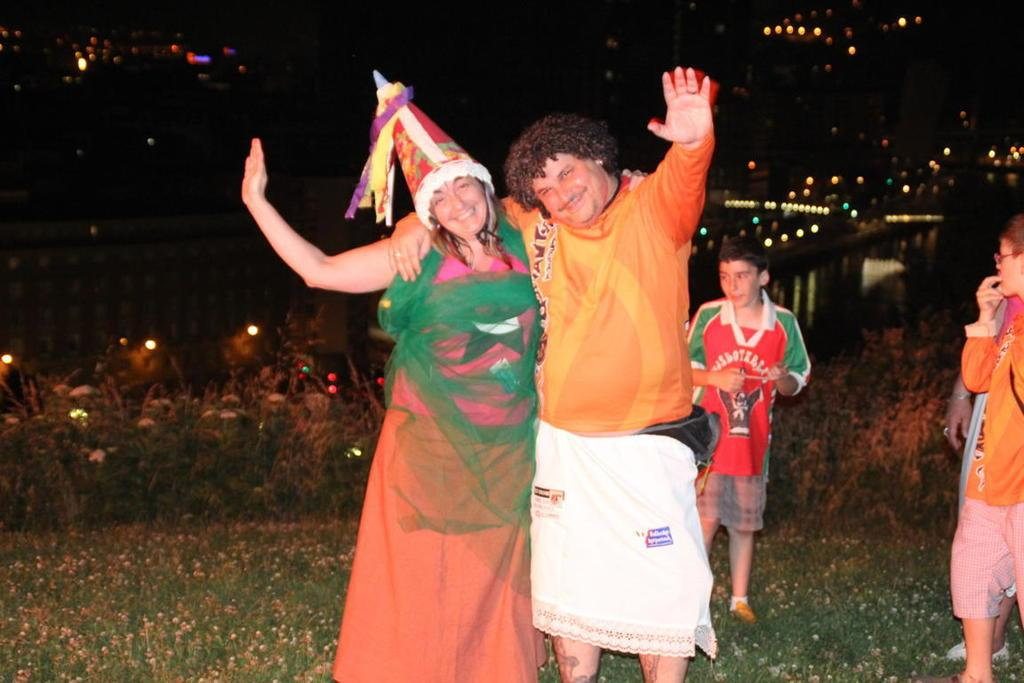Who or what can be seen in the image? There are people in the image. What else is present in the image besides people? There are plants, lights, and a fence in the image. What type of key is used to unlock the sun in the image? There is no sun or key present in the image. 